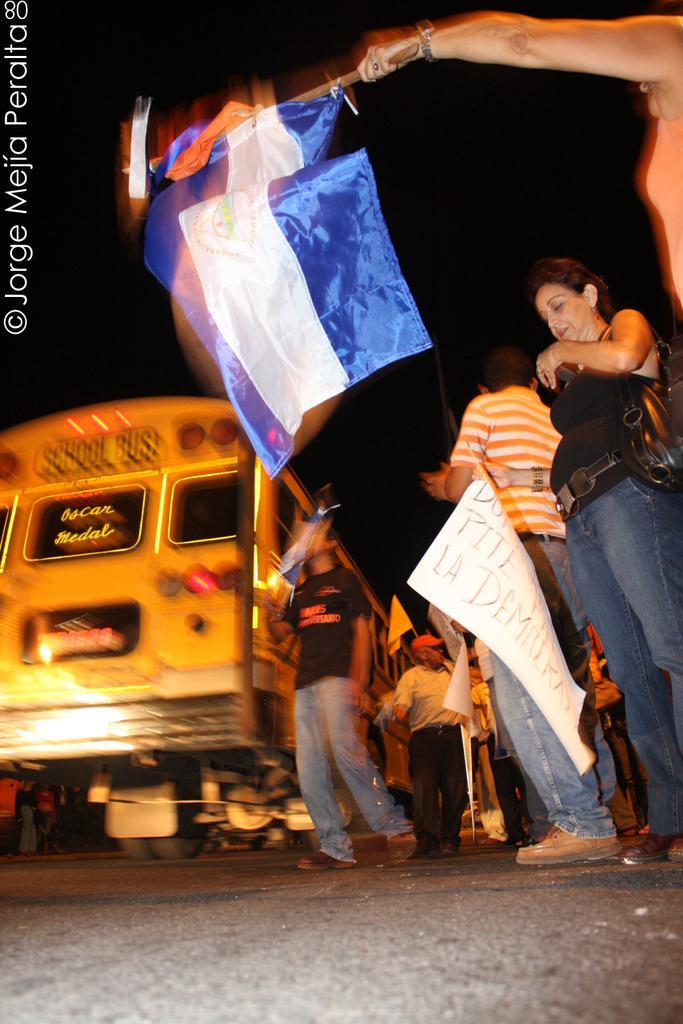How would you summarize this image in a sentence or two? In this image there are group of people one person is holding flags, and some of them are holding some placards. And at the bottom there is road, and in the background there is vehicle and some objects. And on the left side of the image there is text and there is dark background. 